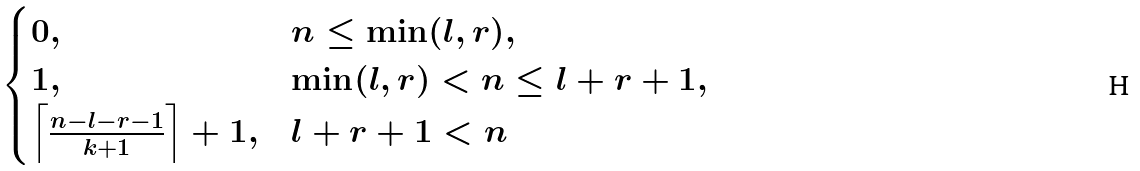Convert formula to latex. <formula><loc_0><loc_0><loc_500><loc_500>\begin{cases} 0 , & n \leq \min ( l , r ) , \\ 1 , & \min ( l , r ) < n \leq l + r + 1 , \\ \left \lceil \frac { n - l - r - 1 } { k + 1 } \right \rceil + 1 , & l + r + 1 < n \end{cases}</formula> 